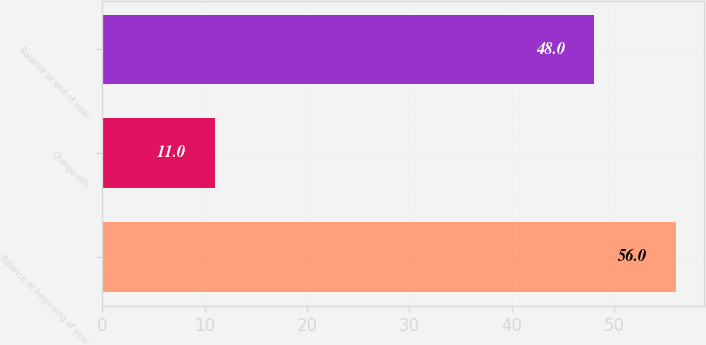Convert chart. <chart><loc_0><loc_0><loc_500><loc_500><bar_chart><fcel>Balance at beginning of year<fcel>Charge-offs<fcel>Balance at end of year<nl><fcel>56<fcel>11<fcel>48<nl></chart> 